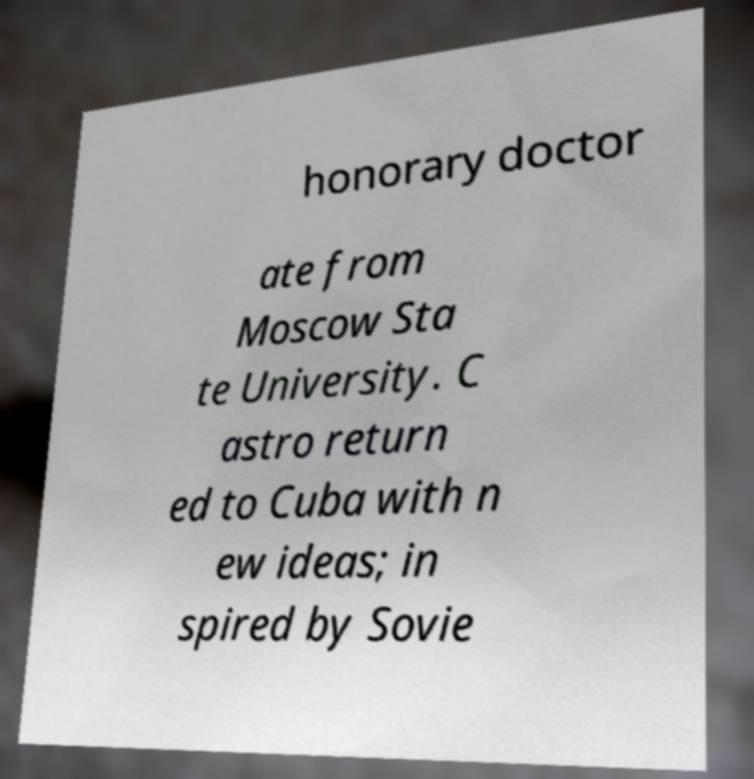Could you assist in decoding the text presented in this image and type it out clearly? honorary doctor ate from Moscow Sta te University. C astro return ed to Cuba with n ew ideas; in spired by Sovie 